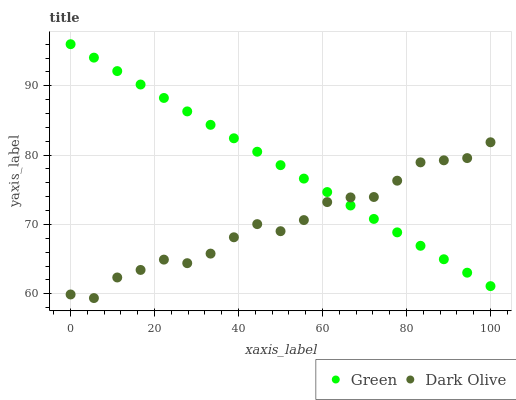Does Dark Olive have the minimum area under the curve?
Answer yes or no. Yes. Does Green have the maximum area under the curve?
Answer yes or no. Yes. Does Green have the minimum area under the curve?
Answer yes or no. No. Is Green the smoothest?
Answer yes or no. Yes. Is Dark Olive the roughest?
Answer yes or no. Yes. Is Green the roughest?
Answer yes or no. No. Does Dark Olive have the lowest value?
Answer yes or no. Yes. Does Green have the lowest value?
Answer yes or no. No. Does Green have the highest value?
Answer yes or no. Yes. Does Dark Olive intersect Green?
Answer yes or no. Yes. Is Dark Olive less than Green?
Answer yes or no. No. Is Dark Olive greater than Green?
Answer yes or no. No. 